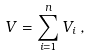<formula> <loc_0><loc_0><loc_500><loc_500>V = \sum _ { i = 1 } ^ { n } V _ { i } \, ,</formula> 